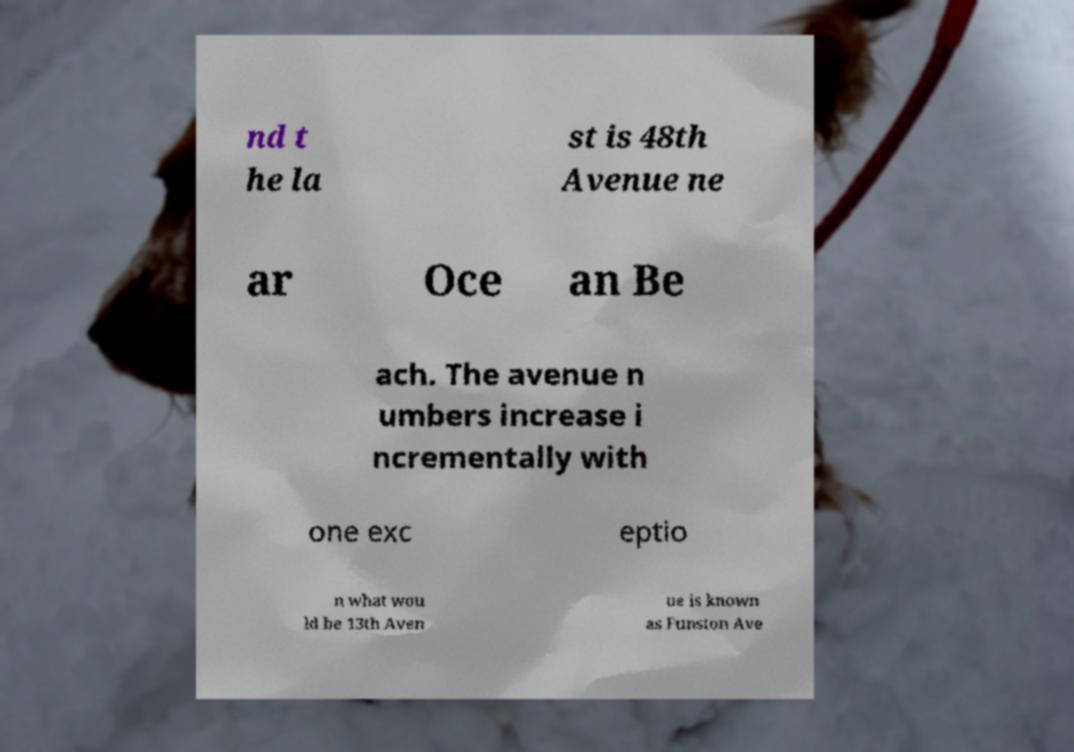Could you extract and type out the text from this image? nd t he la st is 48th Avenue ne ar Oce an Be ach. The avenue n umbers increase i ncrementally with one exc eptio n what wou ld be 13th Aven ue is known as Funston Ave 